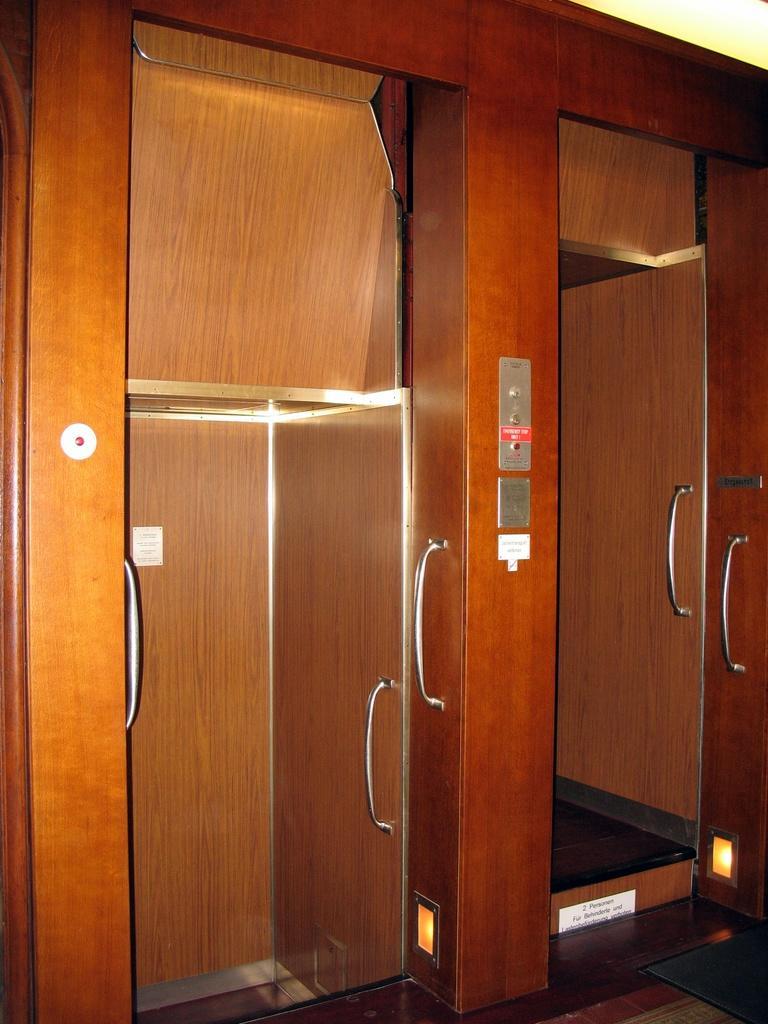Please provide a concise description of this image. In the foreground of this image, there are two elevators and in the middle, there are buttons. 